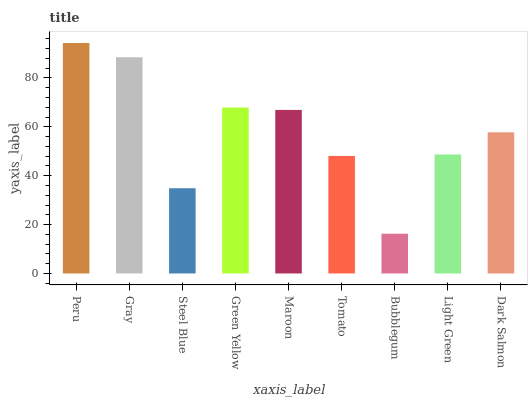Is Bubblegum the minimum?
Answer yes or no. Yes. Is Peru the maximum?
Answer yes or no. Yes. Is Gray the minimum?
Answer yes or no. No. Is Gray the maximum?
Answer yes or no. No. Is Peru greater than Gray?
Answer yes or no. Yes. Is Gray less than Peru?
Answer yes or no. Yes. Is Gray greater than Peru?
Answer yes or no. No. Is Peru less than Gray?
Answer yes or no. No. Is Dark Salmon the high median?
Answer yes or no. Yes. Is Dark Salmon the low median?
Answer yes or no. Yes. Is Maroon the high median?
Answer yes or no. No. Is Gray the low median?
Answer yes or no. No. 